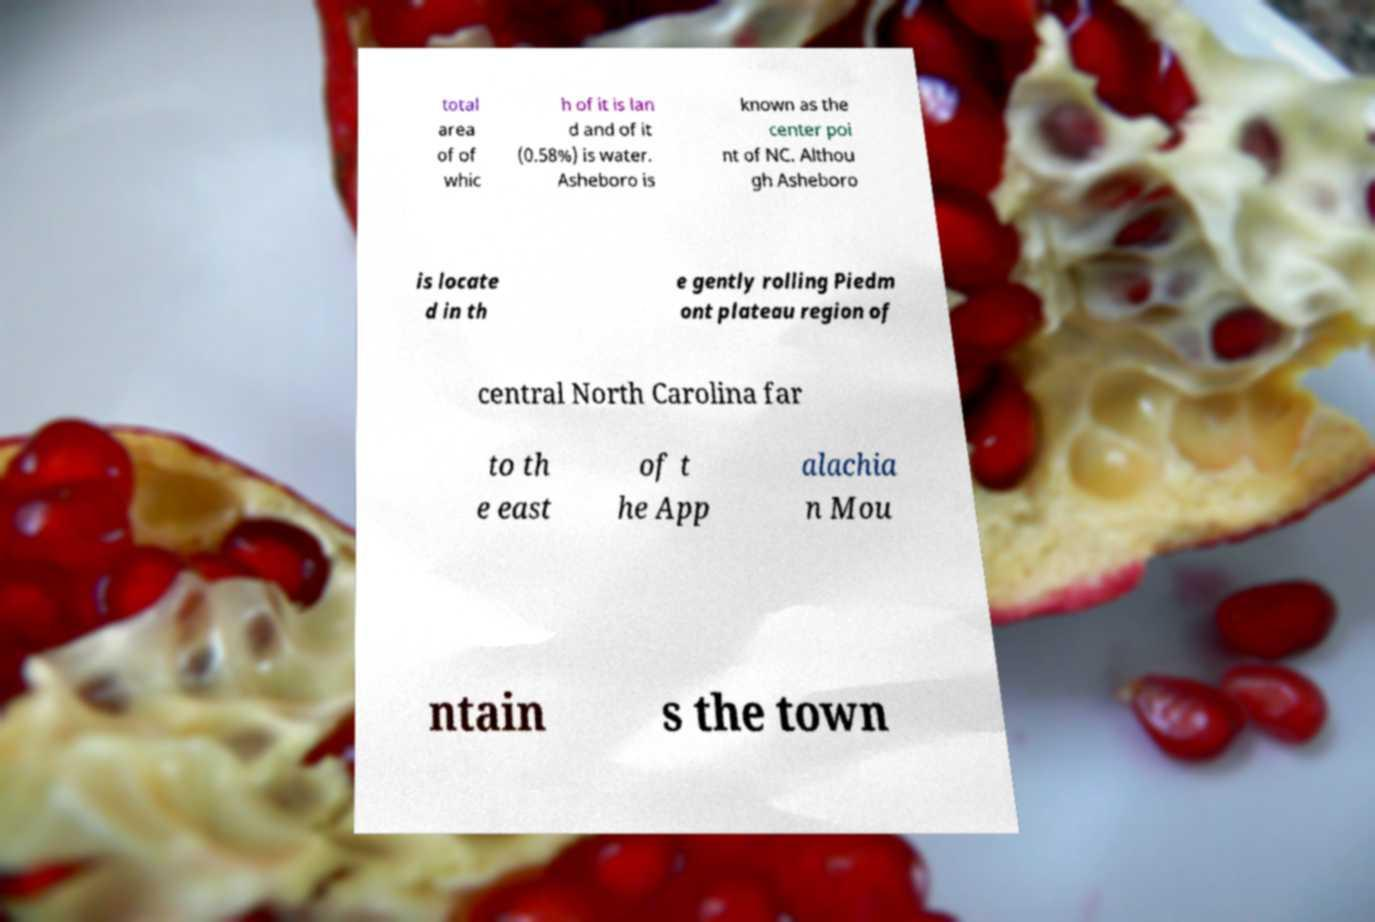Can you accurately transcribe the text from the provided image for me? total area of of whic h of it is lan d and of it (0.58%) is water. Asheboro is known as the center poi nt of NC. Althou gh Asheboro is locate d in th e gently rolling Piedm ont plateau region of central North Carolina far to th e east of t he App alachia n Mou ntain s the town 